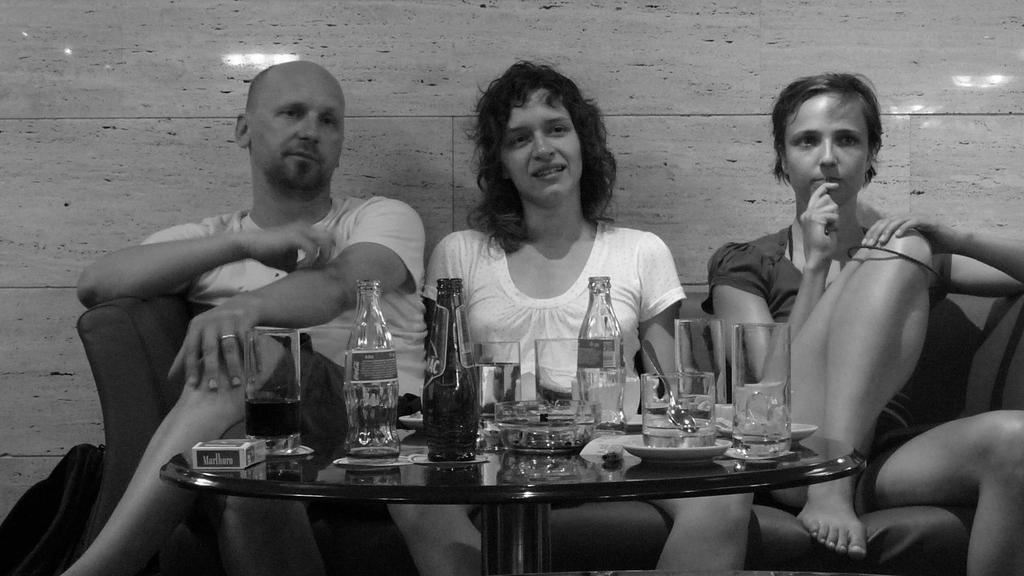Describe this image in one or two sentences. This picture describes about three people they are seated on the sofa in front of them we can find some bottles glasses plates on the table. 